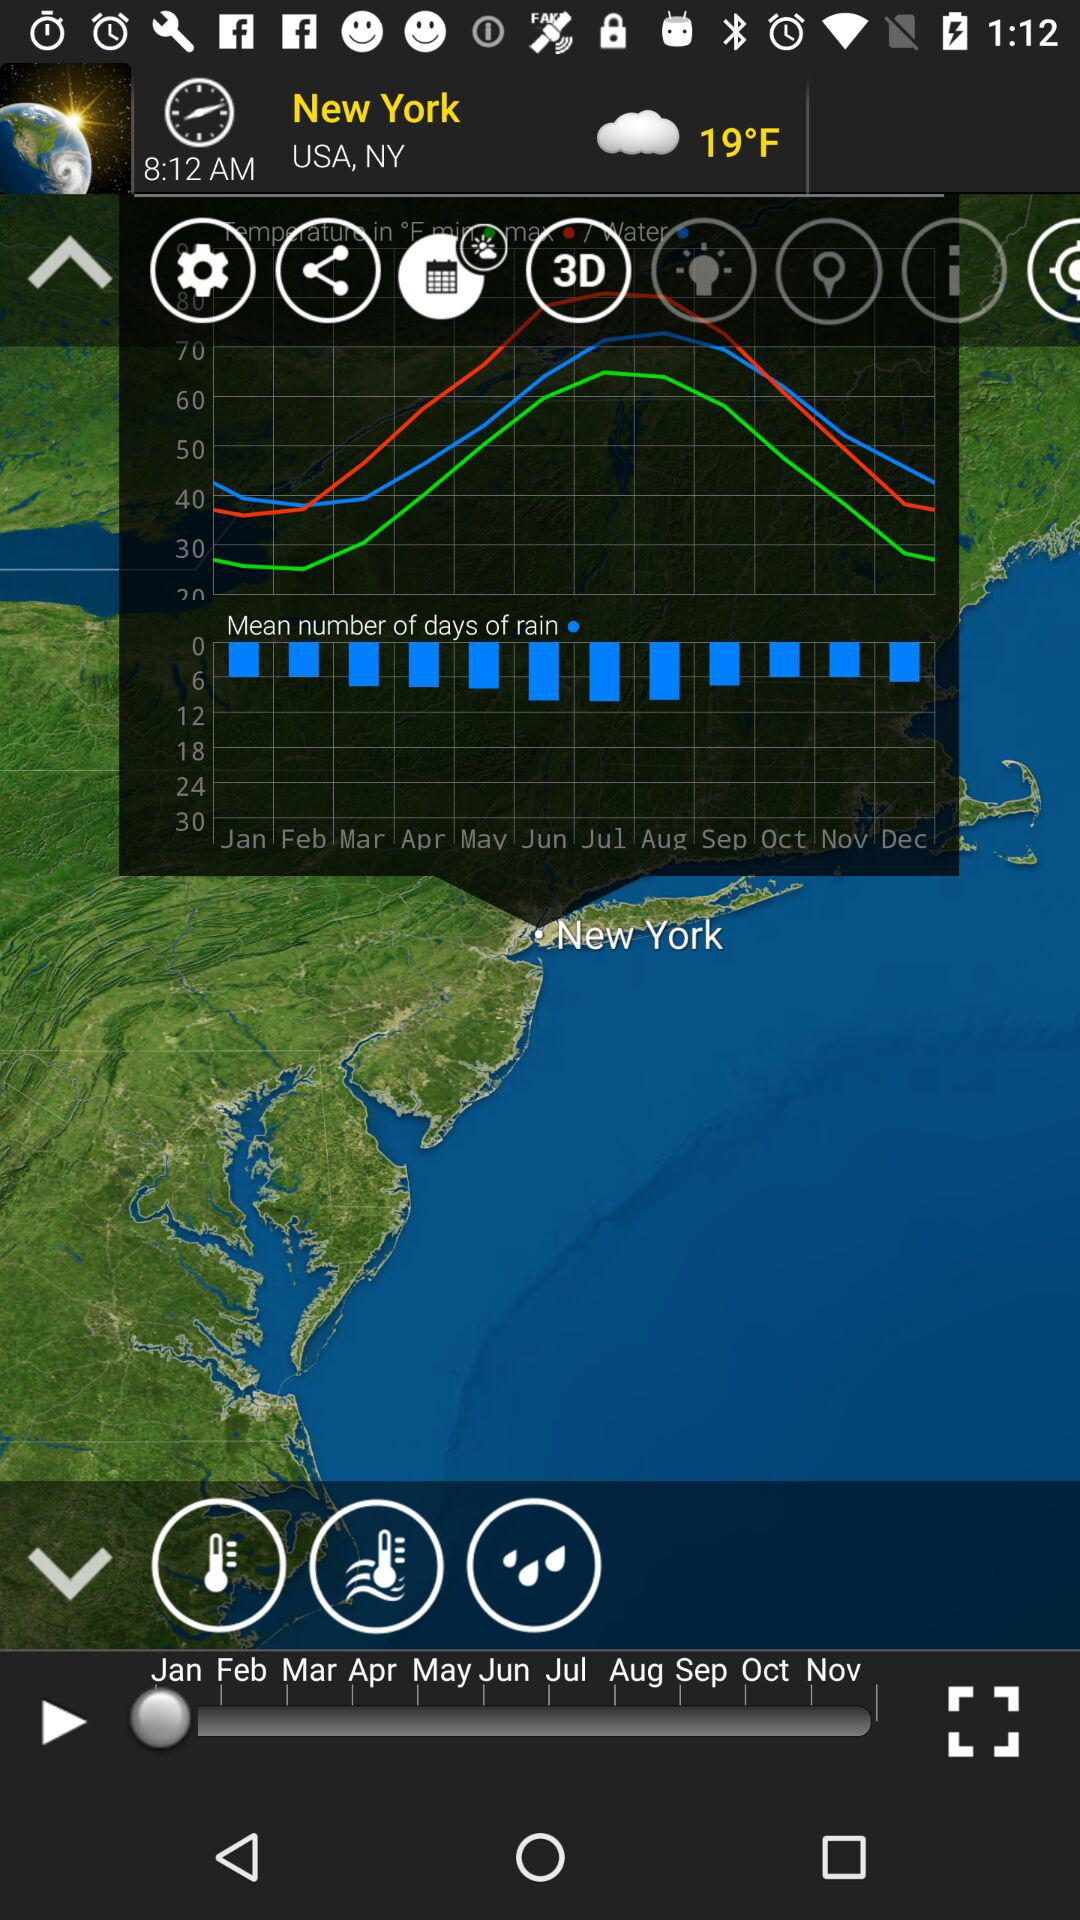How is the weather in New York? The weather is cloudy. 